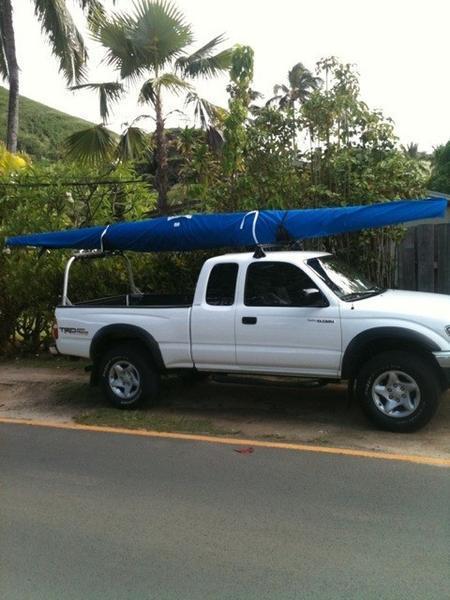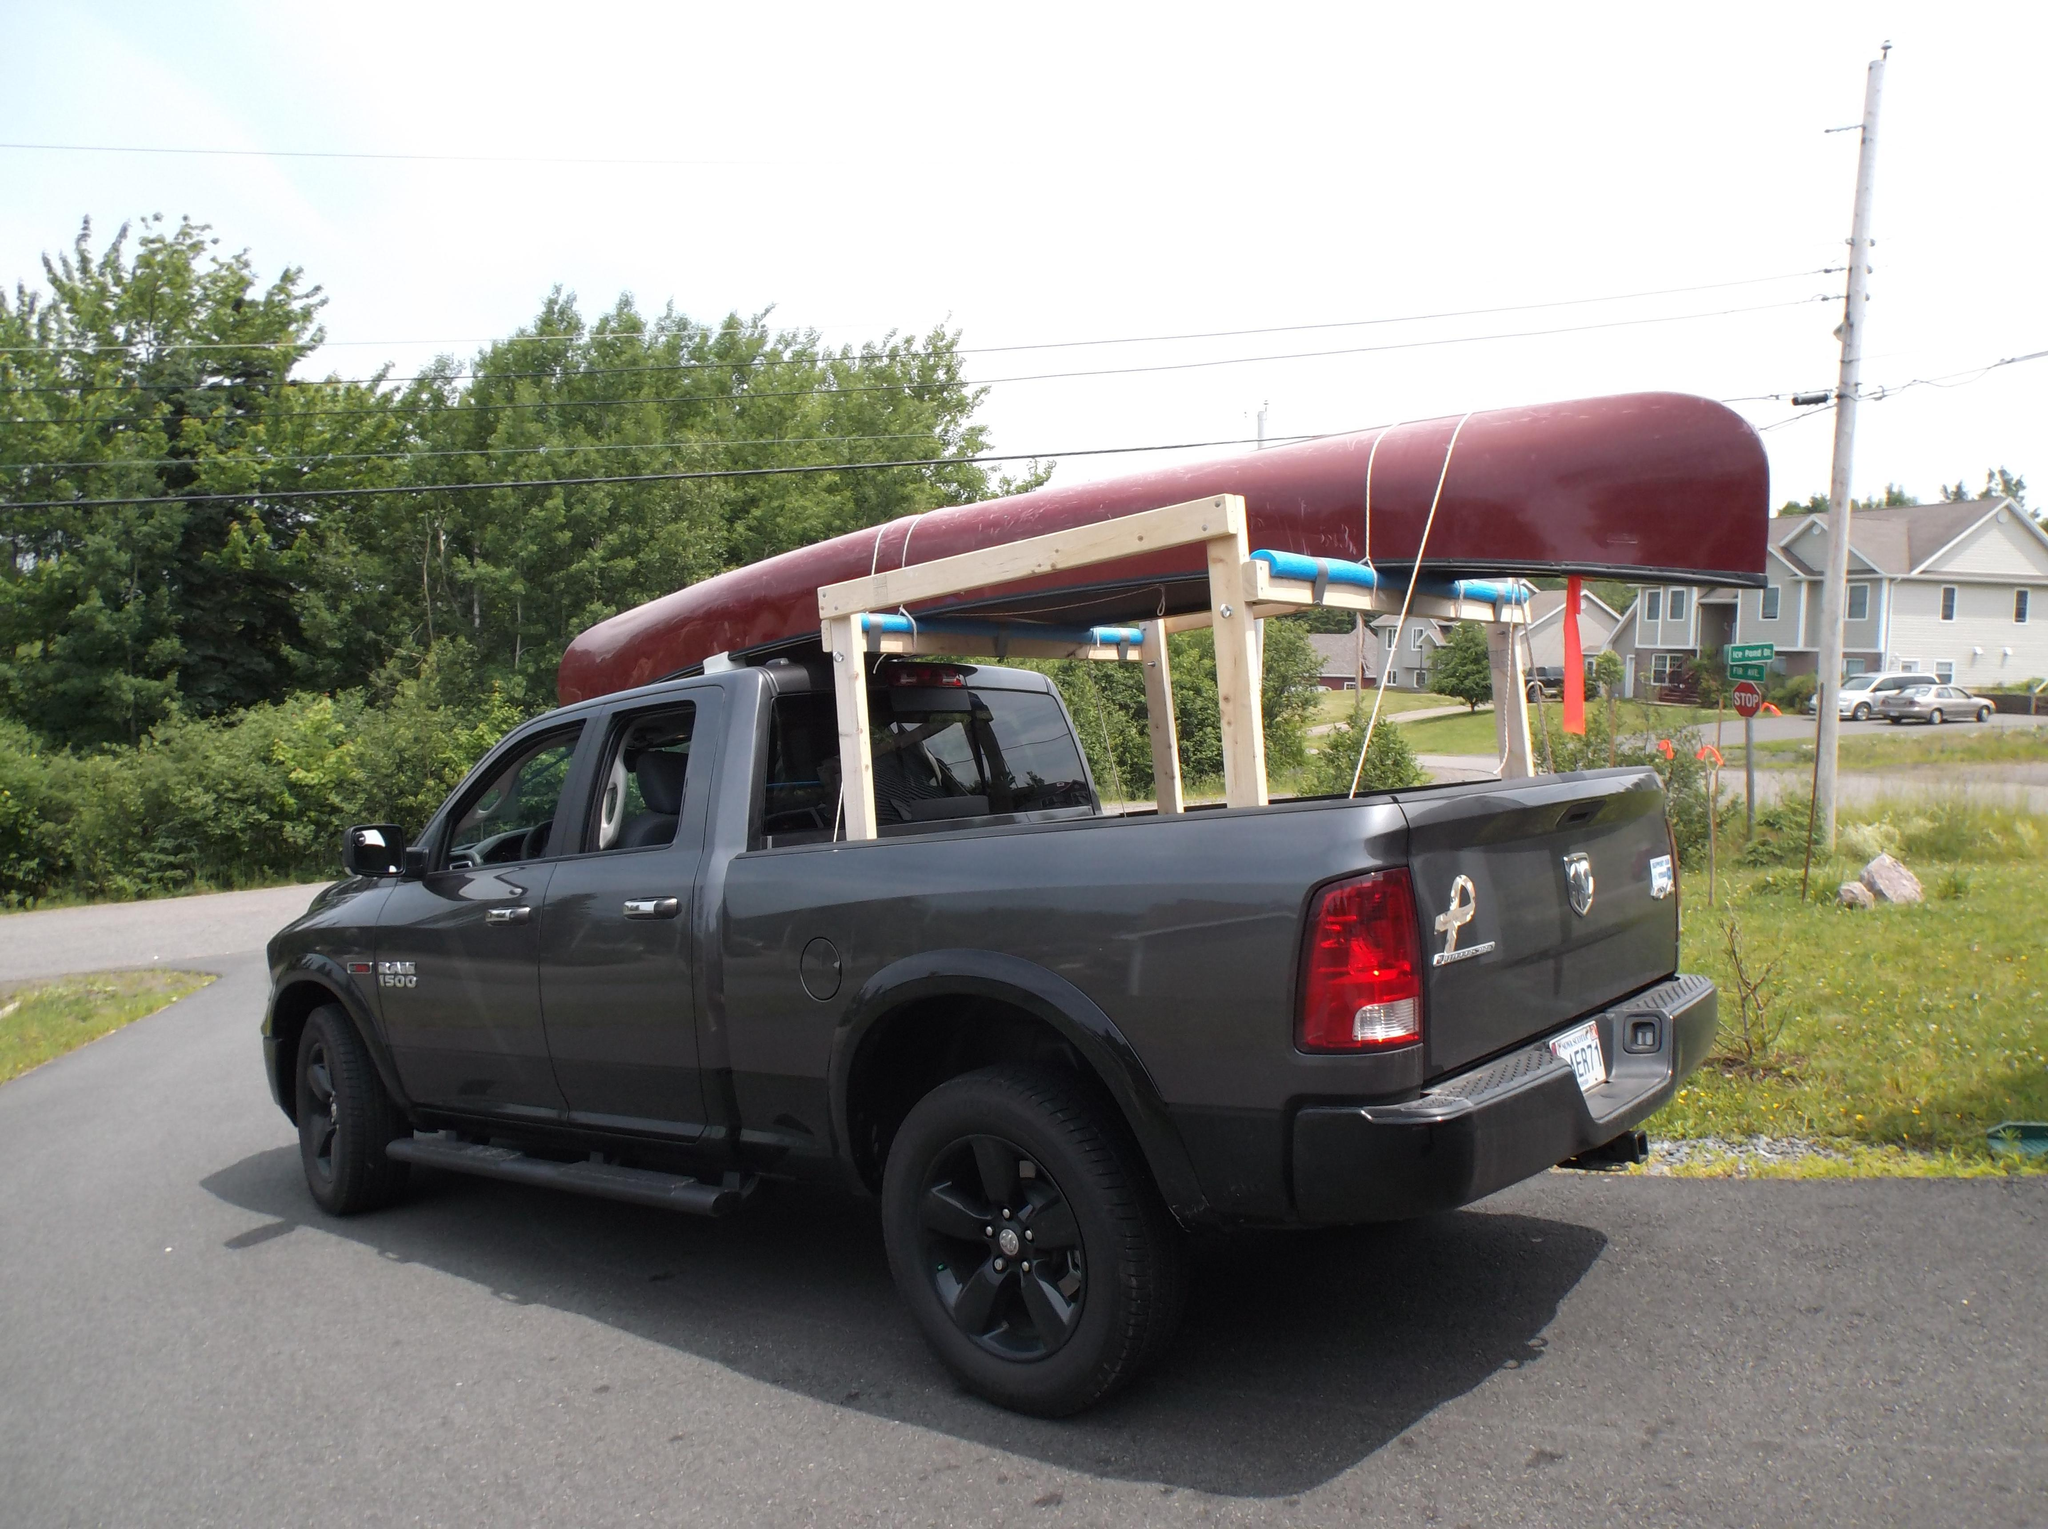The first image is the image on the left, the second image is the image on the right. Analyze the images presented: Is the assertion "One of the images contains at least one red kayak." valid? Answer yes or no. Yes. 